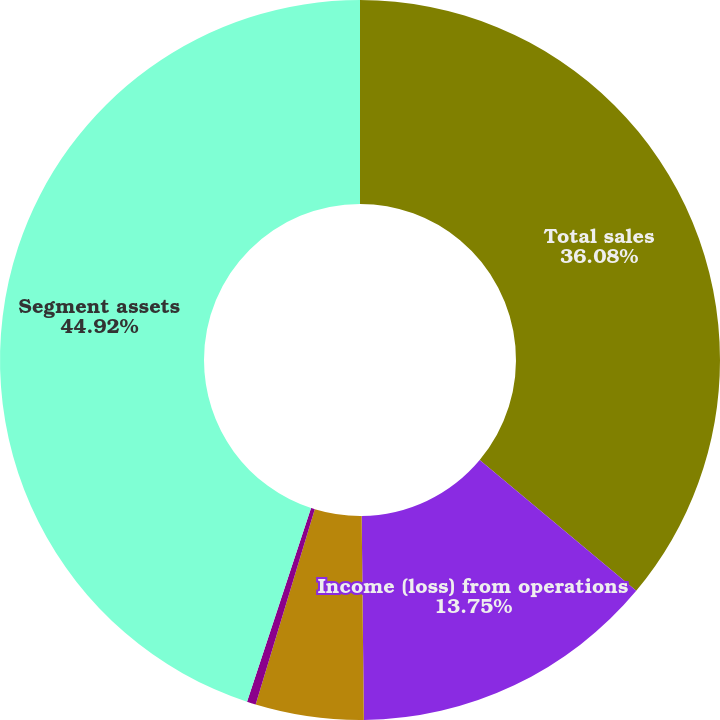<chart> <loc_0><loc_0><loc_500><loc_500><pie_chart><fcel>Total sales<fcel>Income (loss) from operations<fcel>Depreciation and amortization<fcel>Capital expenditures<fcel>Segment assets<nl><fcel>36.08%<fcel>13.75%<fcel>4.85%<fcel>0.4%<fcel>44.92%<nl></chart> 